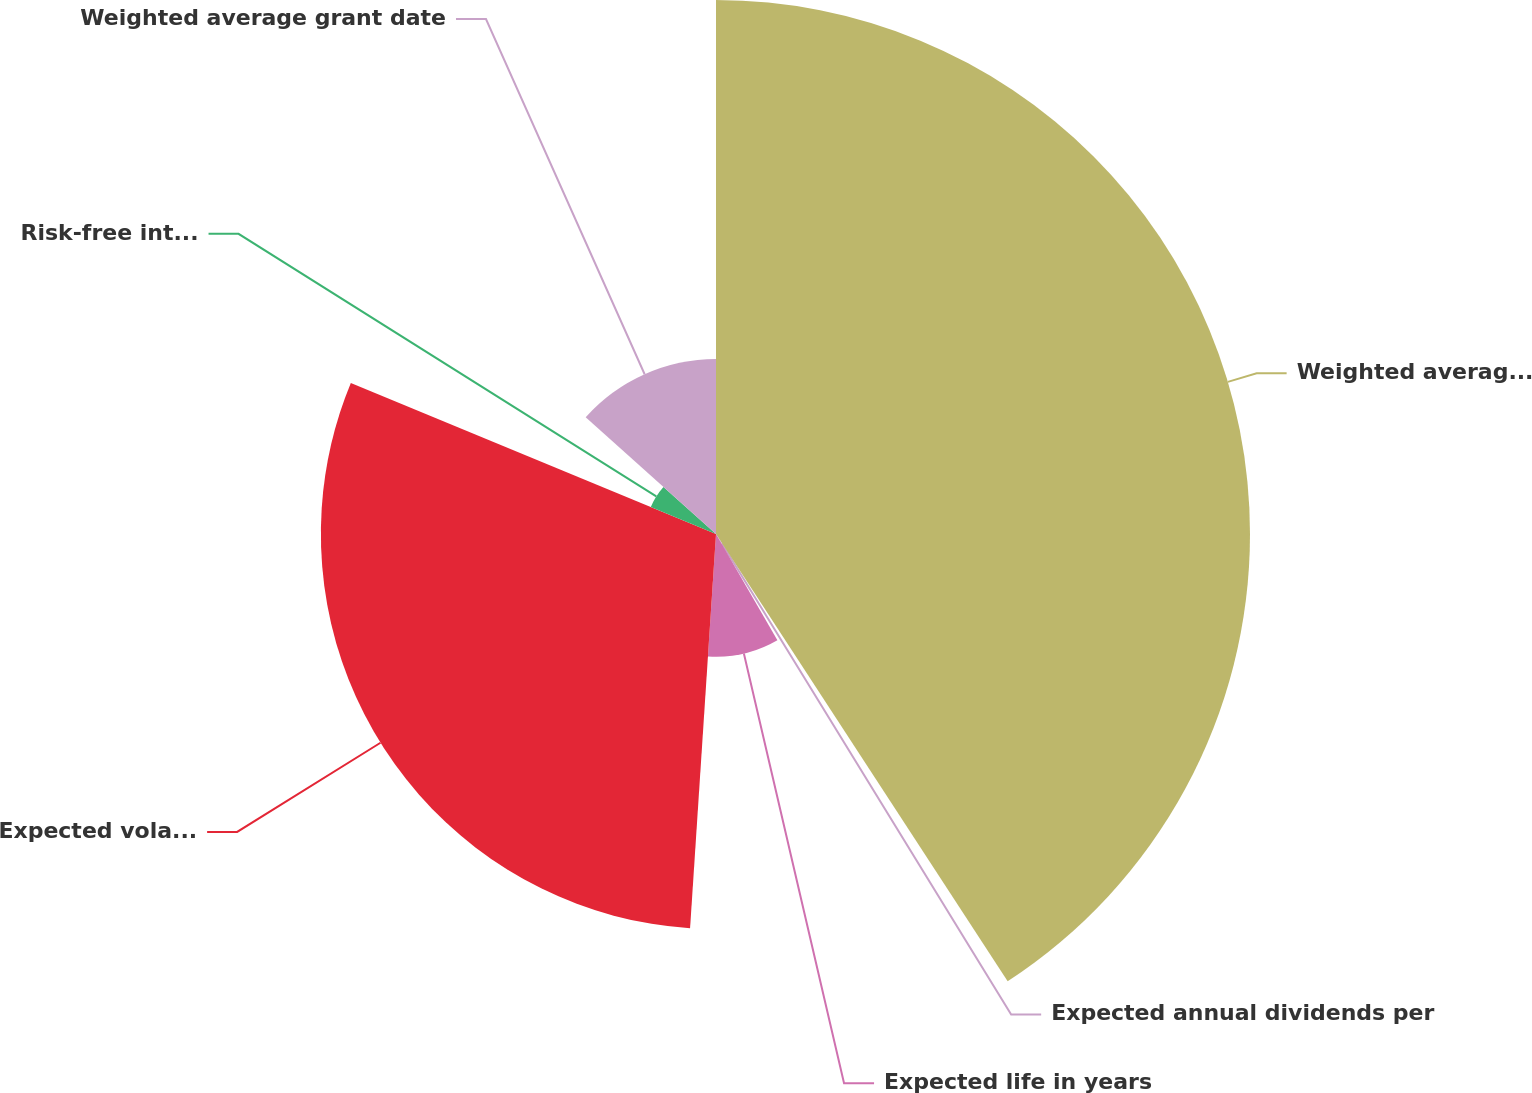Convert chart to OTSL. <chart><loc_0><loc_0><loc_500><loc_500><pie_chart><fcel>Weighted average exercise<fcel>Expected annual dividends per<fcel>Expected life in years<fcel>Expected volatility<fcel>Risk-free interest rate<fcel>Weighted average grant date<nl><fcel>40.8%<fcel>0.86%<fcel>9.38%<fcel>30.19%<fcel>5.39%<fcel>13.37%<nl></chart> 